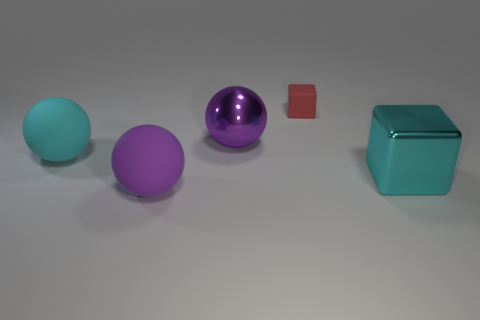How many other objects are there of the same material as the large cyan block?
Provide a short and direct response. 1. What number of other objects are the same color as the big metallic ball?
Offer a terse response. 1. There is a big object that is on the right side of the big metal thing that is behind the cyan matte object; what is its material?
Provide a succinct answer. Metal. Are there any small blocks?
Provide a short and direct response. Yes. There is a metal object on the left side of the block that is left of the big cube; what size is it?
Your answer should be very brief. Large. Is the number of big cyan balls that are behind the big cyan matte object greater than the number of cyan blocks that are in front of the metallic cube?
Ensure brevity in your answer.  No. How many cylinders are either brown metallic things or big shiny things?
Keep it short and to the point. 0. Is there any other thing that is the same size as the cyan cube?
Provide a short and direct response. Yes. There is a thing that is behind the purple metal thing; does it have the same shape as the cyan metallic object?
Offer a terse response. Yes. The metallic cube is what color?
Keep it short and to the point. Cyan. 